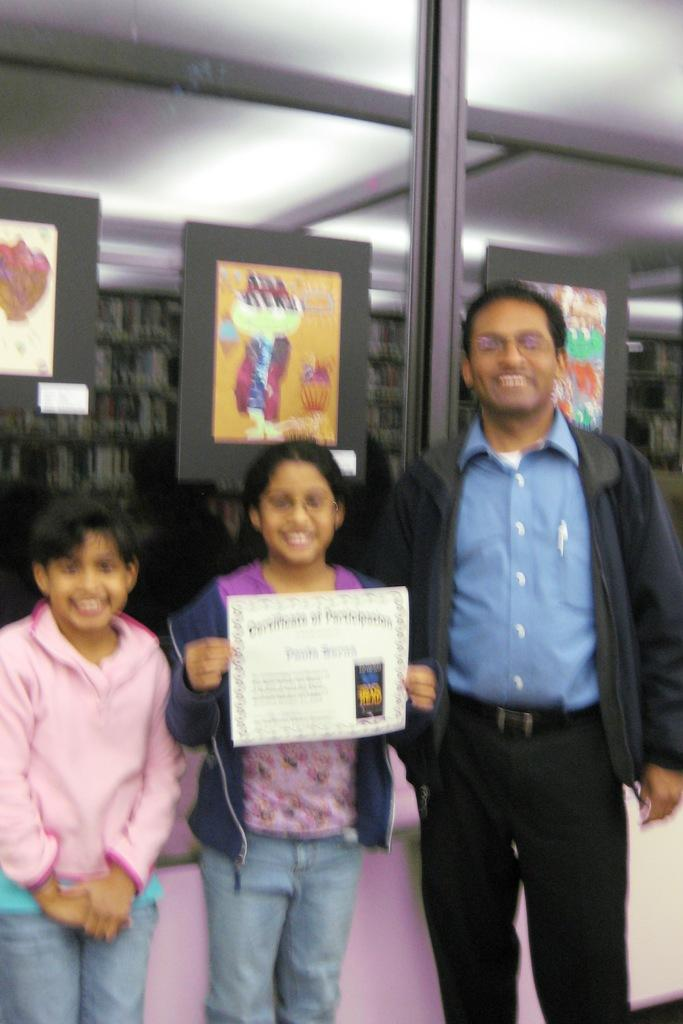Who is present in the image? There is a man and two children in the image. What are the people in the image doing? The man and children are standing and smiling. What is one of the children holding? One of the children is holding a paper. What can be seen in the background of the image? There are posters in the background of the image. How many chickens are visible in the image? There are no chickens present in the image. What type of pollution can be seen in the image? There is no pollution visible in the image. 